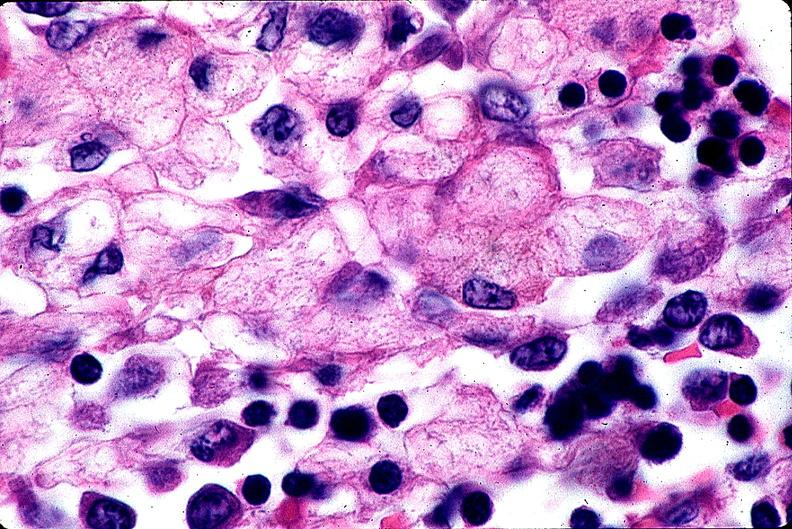does carcinoma metastatic lung show gaucher disease?
Answer the question using a single word or phrase. No 